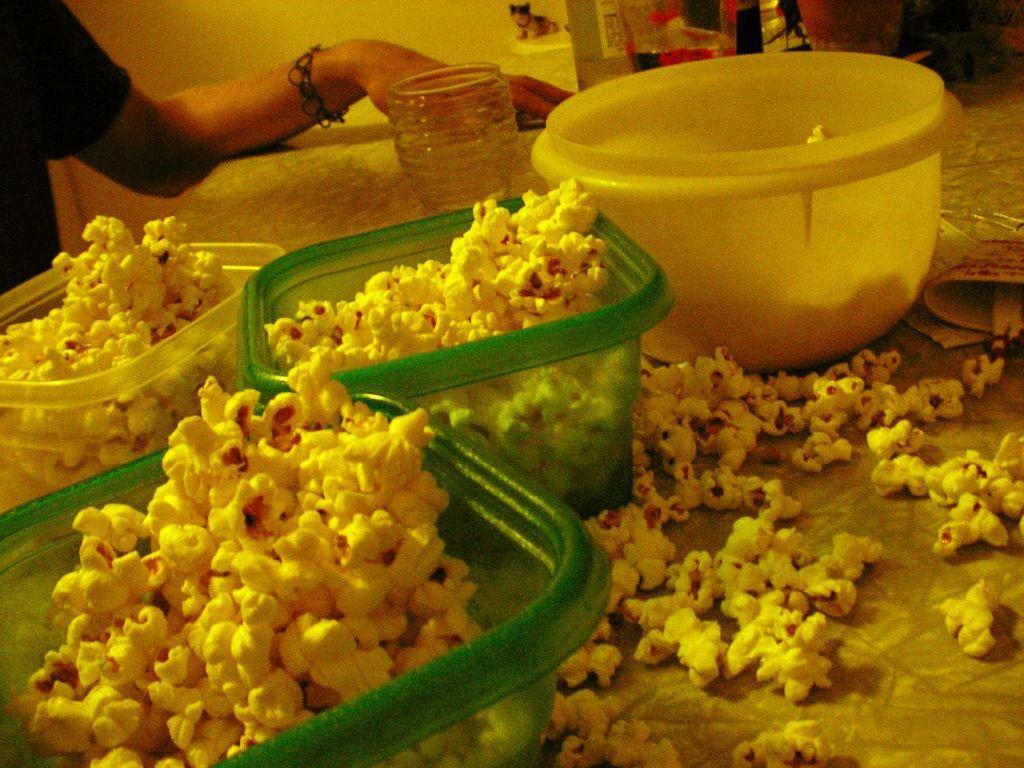In one or two sentences, can you explain what this image depicts? In this picture I can see popcorn in the bowl and in the plastic containers, there are popcorns and some other objects on the table, and in the background there is a hand of a person. 